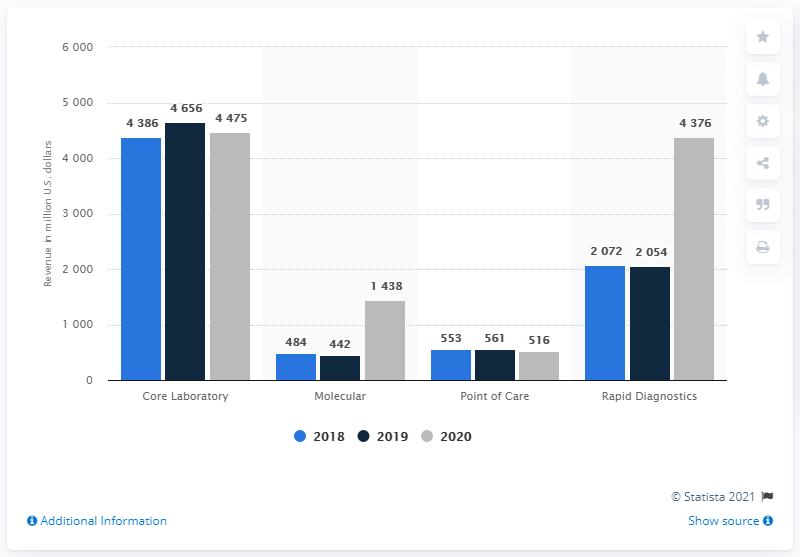Mention a couple of crucial points in this snapshot. Rapid Diagnostics generated revenue of approximately 4,386 in 2020. 